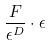<formula> <loc_0><loc_0><loc_500><loc_500>\frac { F } { \epsilon ^ { D } } \cdot \epsilon</formula> 